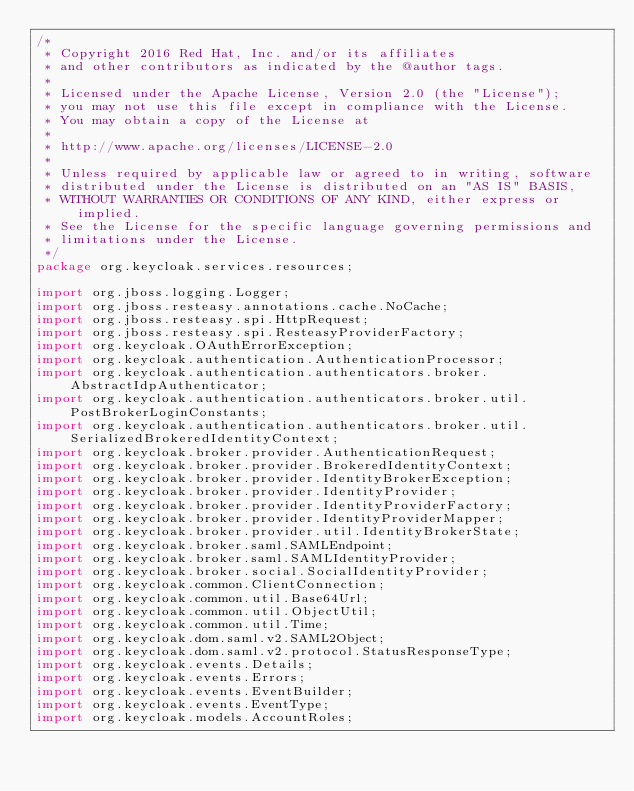Convert code to text. <code><loc_0><loc_0><loc_500><loc_500><_Java_>/*
 * Copyright 2016 Red Hat, Inc. and/or its affiliates
 * and other contributors as indicated by the @author tags.
 *
 * Licensed under the Apache License, Version 2.0 (the "License");
 * you may not use this file except in compliance with the License.
 * You may obtain a copy of the License at
 *
 * http://www.apache.org/licenses/LICENSE-2.0
 *
 * Unless required by applicable law or agreed to in writing, software
 * distributed under the License is distributed on an "AS IS" BASIS,
 * WITHOUT WARRANTIES OR CONDITIONS OF ANY KIND, either express or implied.
 * See the License for the specific language governing permissions and
 * limitations under the License.
 */
package org.keycloak.services.resources;

import org.jboss.logging.Logger;
import org.jboss.resteasy.annotations.cache.NoCache;
import org.jboss.resteasy.spi.HttpRequest;
import org.jboss.resteasy.spi.ResteasyProviderFactory;
import org.keycloak.OAuthErrorException;
import org.keycloak.authentication.AuthenticationProcessor;
import org.keycloak.authentication.authenticators.broker.AbstractIdpAuthenticator;
import org.keycloak.authentication.authenticators.broker.util.PostBrokerLoginConstants;
import org.keycloak.authentication.authenticators.broker.util.SerializedBrokeredIdentityContext;
import org.keycloak.broker.provider.AuthenticationRequest;
import org.keycloak.broker.provider.BrokeredIdentityContext;
import org.keycloak.broker.provider.IdentityBrokerException;
import org.keycloak.broker.provider.IdentityProvider;
import org.keycloak.broker.provider.IdentityProviderFactory;
import org.keycloak.broker.provider.IdentityProviderMapper;
import org.keycloak.broker.provider.util.IdentityBrokerState;
import org.keycloak.broker.saml.SAMLEndpoint;
import org.keycloak.broker.saml.SAMLIdentityProvider;
import org.keycloak.broker.social.SocialIdentityProvider;
import org.keycloak.common.ClientConnection;
import org.keycloak.common.util.Base64Url;
import org.keycloak.common.util.ObjectUtil;
import org.keycloak.common.util.Time;
import org.keycloak.dom.saml.v2.SAML2Object;
import org.keycloak.dom.saml.v2.protocol.StatusResponseType;
import org.keycloak.events.Details;
import org.keycloak.events.Errors;
import org.keycloak.events.EventBuilder;
import org.keycloak.events.EventType;
import org.keycloak.models.AccountRoles;</code> 